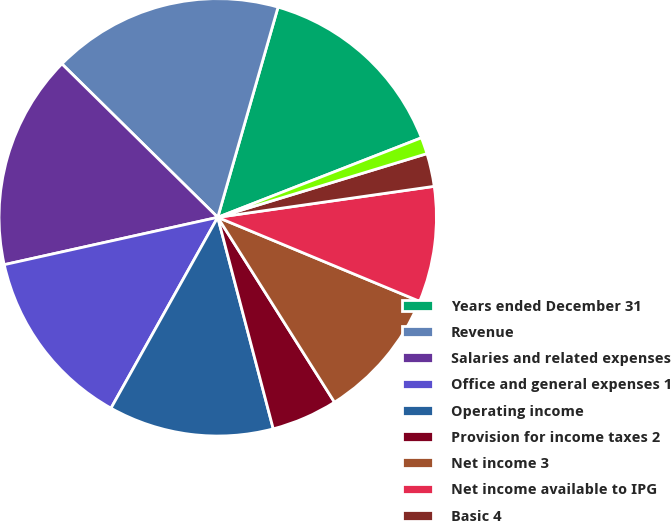<chart> <loc_0><loc_0><loc_500><loc_500><pie_chart><fcel>Years ended December 31<fcel>Revenue<fcel>Salaries and related expenses<fcel>Office and general expenses 1<fcel>Operating income<fcel>Provision for income taxes 2<fcel>Net income 3<fcel>Net income available to IPG<fcel>Basic 4<fcel>Diluted 4<nl><fcel>14.63%<fcel>17.07%<fcel>15.85%<fcel>13.41%<fcel>12.2%<fcel>4.88%<fcel>9.76%<fcel>8.54%<fcel>2.44%<fcel>1.22%<nl></chart> 